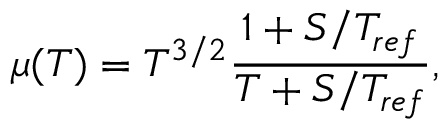<formula> <loc_0><loc_0><loc_500><loc_500>\mu ( T ) = T ^ { 3 / 2 } \frac { 1 + S / T _ { r e f } } { T + S / T _ { r e f } } ,</formula> 